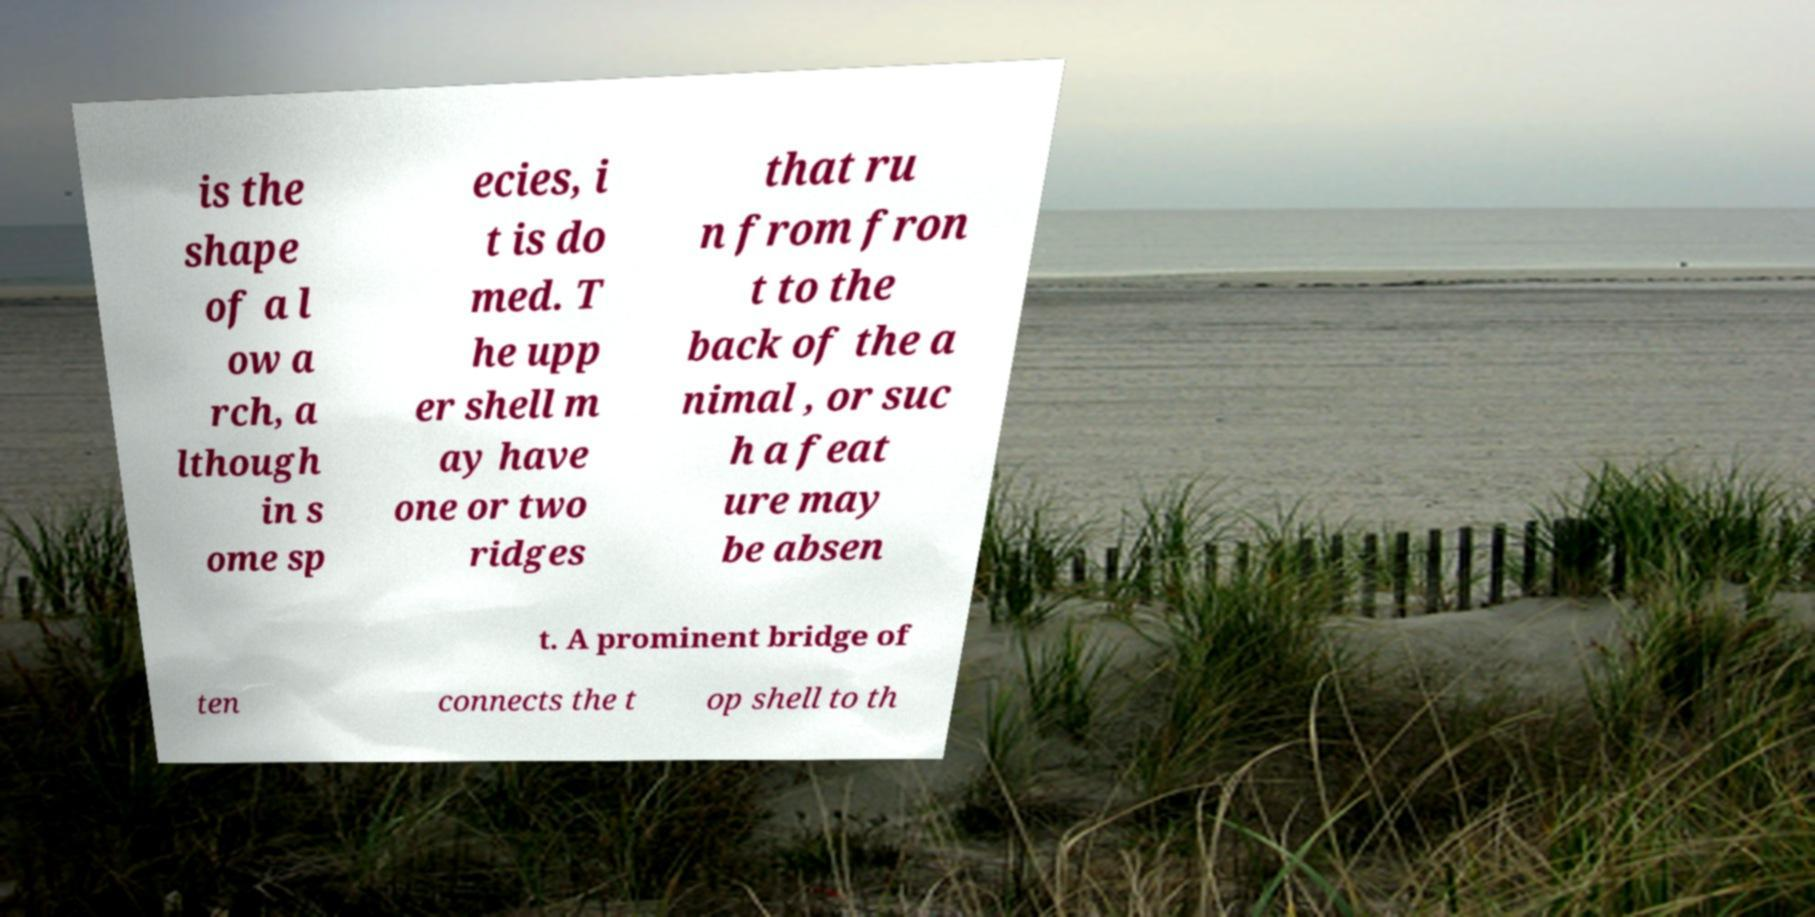Can you accurately transcribe the text from the provided image for me? is the shape of a l ow a rch, a lthough in s ome sp ecies, i t is do med. T he upp er shell m ay have one or two ridges that ru n from fron t to the back of the a nimal , or suc h a feat ure may be absen t. A prominent bridge of ten connects the t op shell to th 